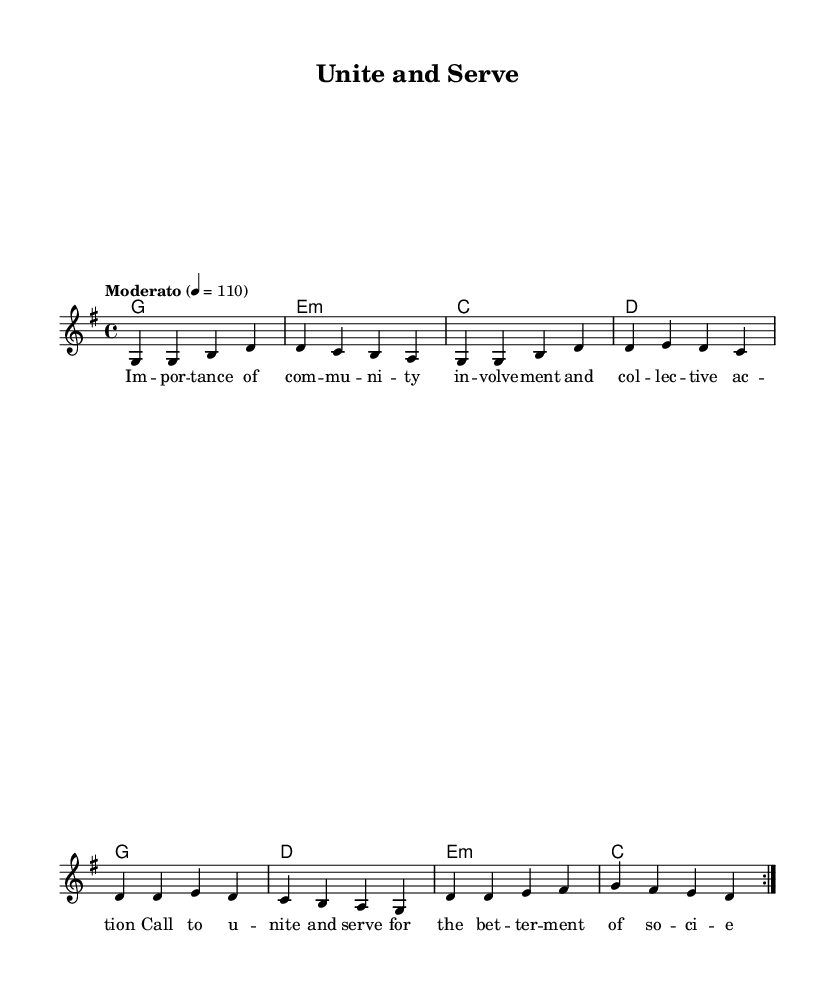What is the key signature of this music? The key signature is G major, which has one sharp (F#). We can determine this from the information given in the global context of the sheet music.
Answer: G major What is the time signature of this music? The time signature is 4/4, indicated in the global context section of the score. This means there are four beats in each measure and a quarter note receives one beat.
Answer: 4/4 What is the tempo marking for this music? The tempo marking is "Moderato" with a metronome marking of quarter note equals 110. This is specified in the tempo directive of the global context.
Answer: Moderato, 110 How many measures are in the melody? The melody has 8 measures as indicated by the repeated volta and the specific note groupings that sum up to 8 separate phrases in the music score.
Answer: 8 What is the lyrical theme of the piece? The lyrics emphasize the importance of community involvement and collective action alongside a call for unity and service for the betterment of society. This can be discerned from the content of the verseWords section.
Answer: Community involvement How many chord changes occur in the harmonies? There are three chord changes in the harmonic sequence, which can be counted by identifying the chords represented in the chordmode section, repeating twice through the given harmonies.
Answer: 3 What type of music fusion does this piece represent? This piece represents a fusion of rock-influenced devotional music emphasizing social responsibility. The combination of rock elements in the melody and the thematic focus on community support indicates this style.
Answer: Rock-influenced devotional music 